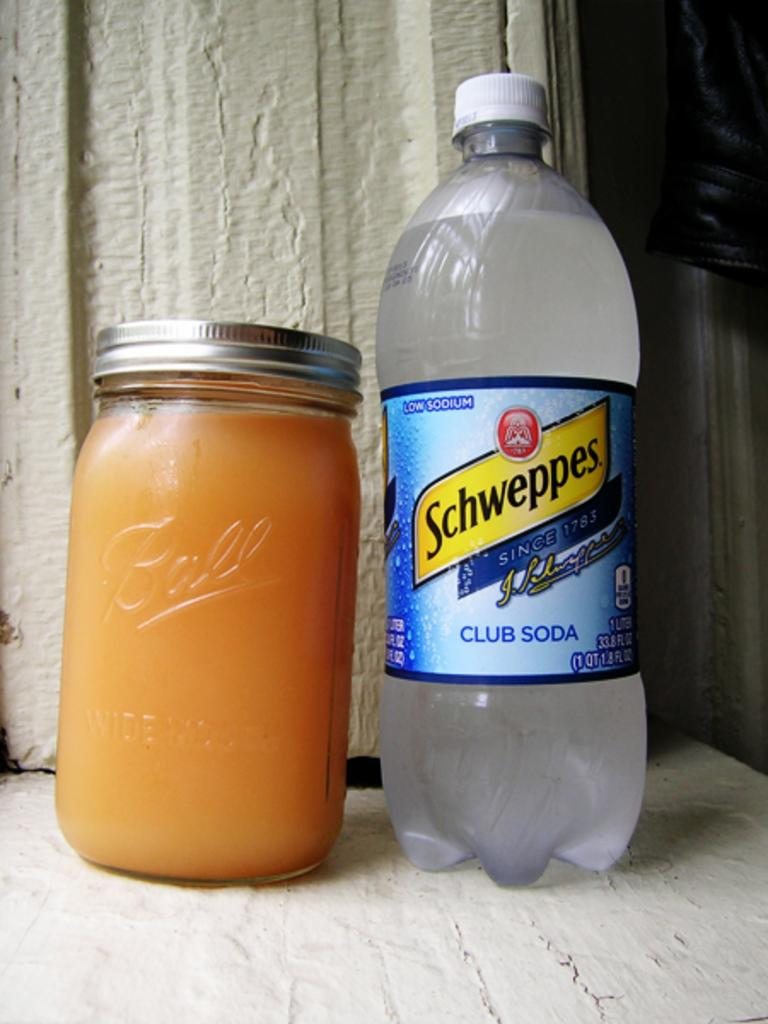What is on the bottle in the image? There is a sticker on the bottle in the image. What is inside the bottle? The bottle contains a drink. What other container is present in the image? There is a jar in the image. Where are the bottle and jar located in the image? Both the bottle and the jar are placed on the floor. Can you see a monkey touching the power lines in the image? No, there is no monkey or power lines present in the image. 